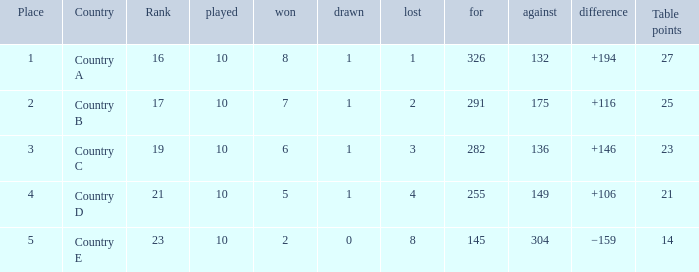 How many table points are listed for the deficit is +194?  1.0. 